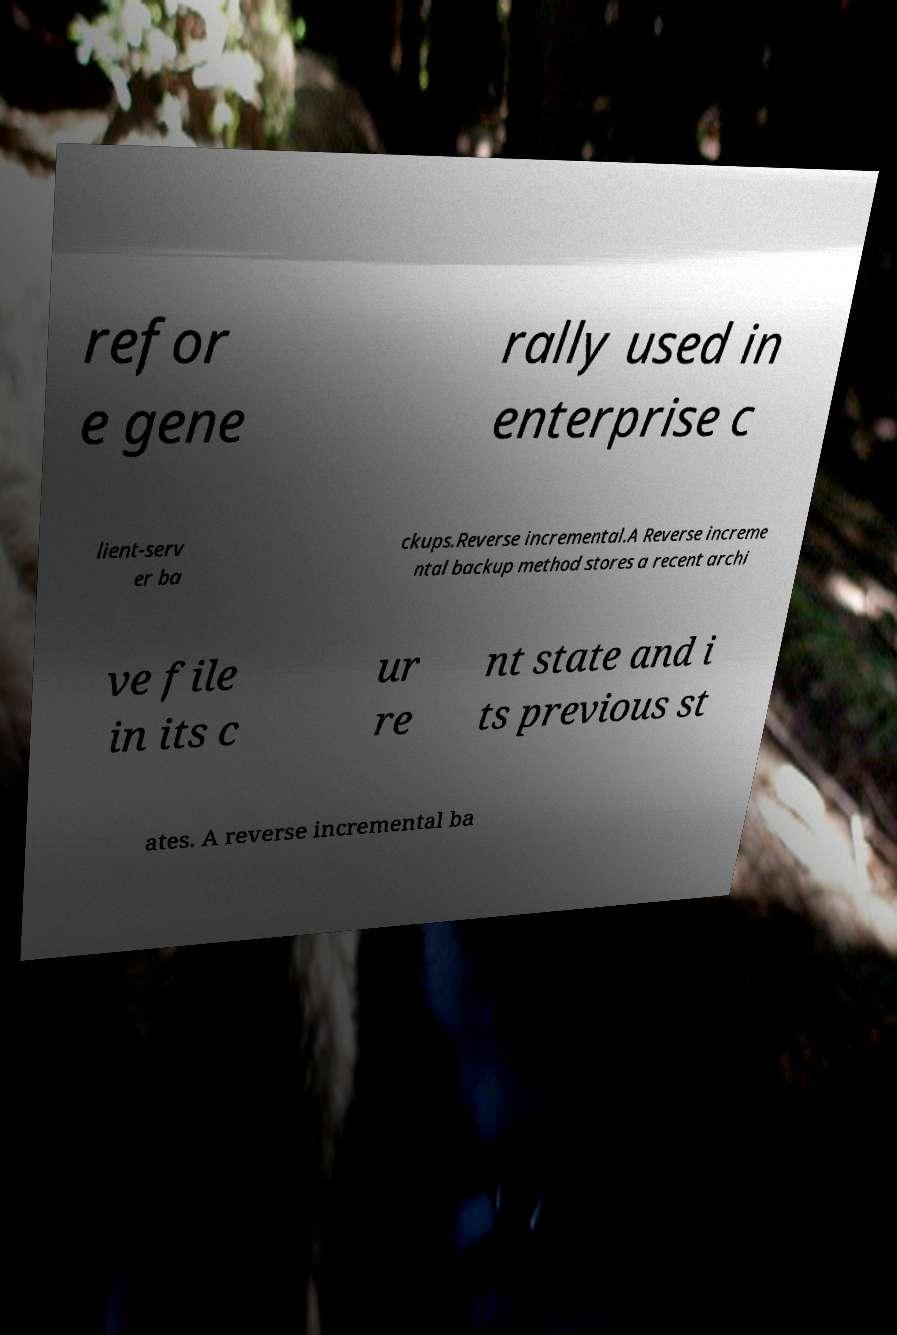Could you assist in decoding the text presented in this image and type it out clearly? refor e gene rally used in enterprise c lient-serv er ba ckups.Reverse incremental.A Reverse increme ntal backup method stores a recent archi ve file in its c ur re nt state and i ts previous st ates. A reverse incremental ba 